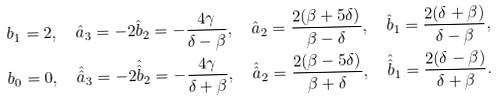Convert formula to latex. <formula><loc_0><loc_0><loc_500><loc_500>& b _ { 1 } = 2 , \quad \hat { a } _ { 3 } = - 2 \hat { b } _ { 2 } = - \frac { 4 \gamma } { \delta - \beta } , \quad \hat { a } _ { 2 } = \frac { 2 ( \beta + 5 \delta ) } { \beta - \delta } , \quad \hat { b } _ { 1 } = \frac { 2 ( \delta + \beta ) } { \delta - \beta } , \\ & b _ { 0 } = 0 , \quad \hat { \hat { a } } _ { 3 } = - 2 \hat { \hat { b } } _ { 2 } = - \frac { 4 \gamma } { \delta + \beta } , \quad \hat { \hat { a } } _ { 2 } = \frac { 2 ( \beta - 5 \delta ) } { \beta + \delta } , \quad \hat { \hat { b } } _ { 1 } = \frac { 2 ( \delta - \beta ) } { \delta + \beta } .</formula> 